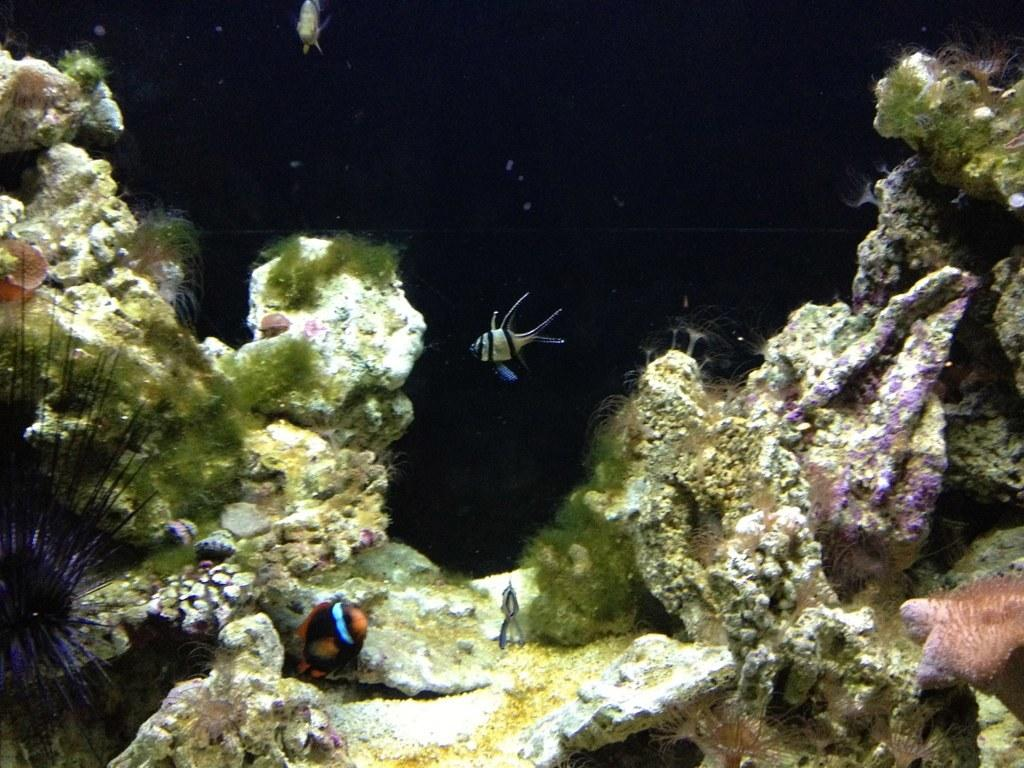What types of animals can be seen in the image? There are different types of fishes in the image. What are the fishes doing in the image? The fishes are moving in the water. What can be seen under the water in the image? There are rocks and plants visible under the water. What time does the hour hand point to in the image? There is no clock or hour hand present in the image; it features different types of fishes moving in the water with rocks and plants visible under the water. 